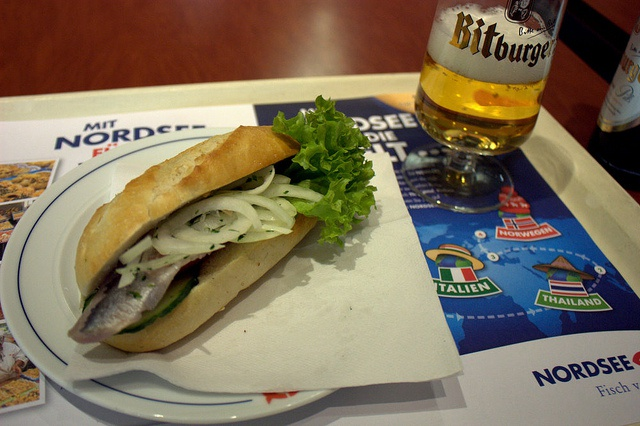Describe the objects in this image and their specific colors. I can see dining table in darkgray, maroon, tan, and beige tones, sandwich in maroon, olive, tan, and black tones, bottle in maroon, black, gray, and olive tones, and bottle in maroon, black, and gray tones in this image. 